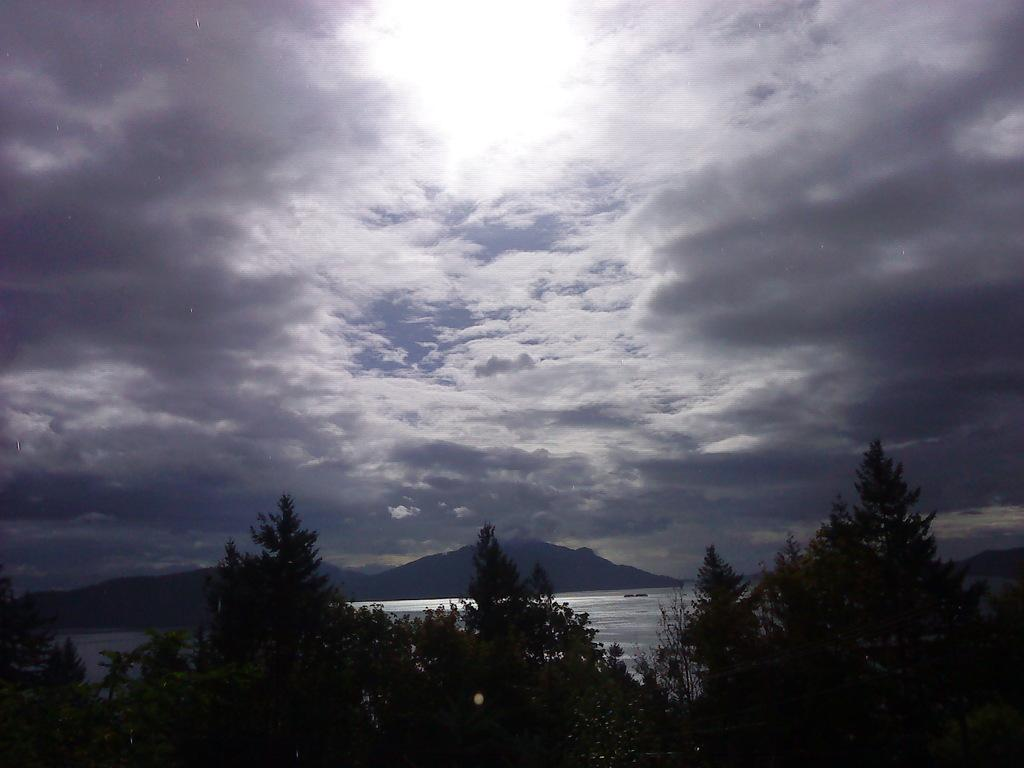What type of natural landform can be seen in the image? There are mountains in the image. What other natural elements are present in the image? There are trees and water visible in the image. What part of the natural environment is visible in the image? The sky is visible in the image. How does the grandfather contribute to the image? There is no mention of a grandfather in the image, so it cannot be determined how he might contribute. 